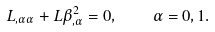Convert formula to latex. <formula><loc_0><loc_0><loc_500><loc_500>L _ { , \alpha \alpha } + L \beta ^ { 2 } _ { , \alpha } = 0 , \quad \alpha = 0 , 1 .</formula> 